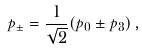Convert formula to latex. <formula><loc_0><loc_0><loc_500><loc_500>p _ { \pm } = \frac { 1 } { \sqrt { 2 } } ( p _ { 0 } \pm p _ { 3 } ) \, ,</formula> 